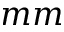<formula> <loc_0><loc_0><loc_500><loc_500>m m</formula> 